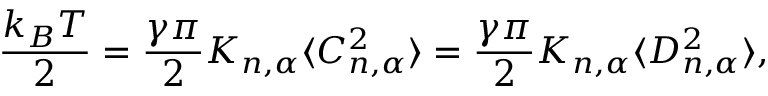<formula> <loc_0><loc_0><loc_500><loc_500>\frac { k _ { B } T } { 2 } = \frac { \gamma \pi } { 2 } K _ { n , \alpha } \langle C _ { n , \alpha } ^ { 2 } \rangle = \frac { \gamma \pi } { 2 } K _ { n , \alpha } \langle D _ { n , \alpha } ^ { 2 } \rangle ,</formula> 